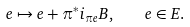<formula> <loc_0><loc_0><loc_500><loc_500>e \mapsto e + \pi ^ { * } i _ { \pi e } B , \quad e \in E .</formula> 